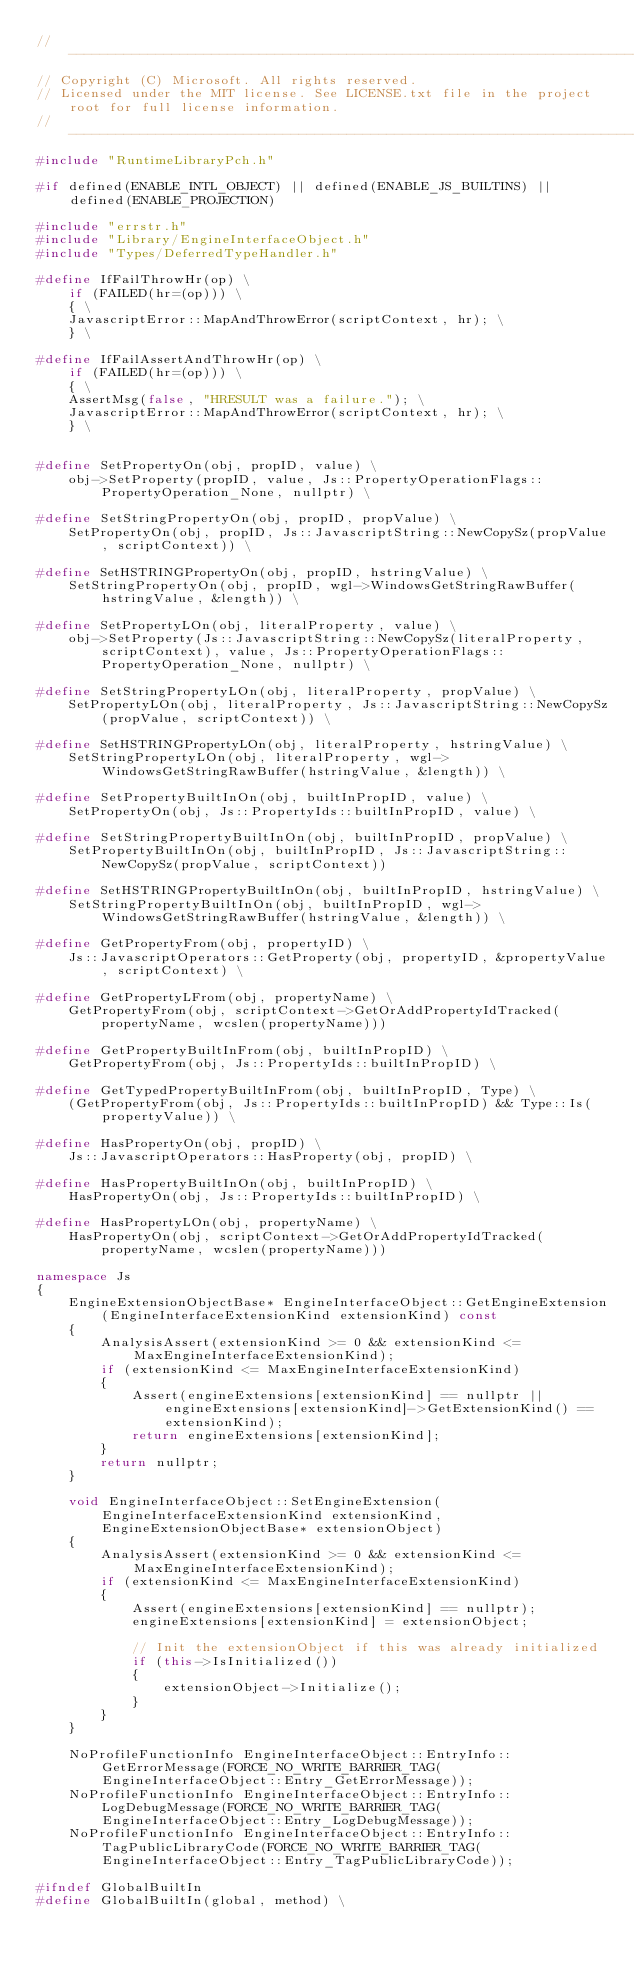<code> <loc_0><loc_0><loc_500><loc_500><_C++_>//-------------------------------------------------------------------------------------------------------
// Copyright (C) Microsoft. All rights reserved.
// Licensed under the MIT license. See LICENSE.txt file in the project root for full license information.
//-------------------------------------------------------------------------------------------------------
#include "RuntimeLibraryPch.h"

#if defined(ENABLE_INTL_OBJECT) || defined(ENABLE_JS_BUILTINS) || defined(ENABLE_PROJECTION)

#include "errstr.h"
#include "Library/EngineInterfaceObject.h"
#include "Types/DeferredTypeHandler.h"

#define IfFailThrowHr(op) \
    if (FAILED(hr=(op))) \
    { \
    JavascriptError::MapAndThrowError(scriptContext, hr); \
    } \

#define IfFailAssertAndThrowHr(op) \
    if (FAILED(hr=(op))) \
    { \
    AssertMsg(false, "HRESULT was a failure."); \
    JavascriptError::MapAndThrowError(scriptContext, hr); \
    } \


#define SetPropertyOn(obj, propID, value) \
    obj->SetProperty(propID, value, Js::PropertyOperationFlags::PropertyOperation_None, nullptr) \

#define SetStringPropertyOn(obj, propID, propValue) \
    SetPropertyOn(obj, propID, Js::JavascriptString::NewCopySz(propValue, scriptContext)) \

#define SetHSTRINGPropertyOn(obj, propID, hstringValue) \
    SetStringPropertyOn(obj, propID, wgl->WindowsGetStringRawBuffer(hstringValue, &length)) \

#define SetPropertyLOn(obj, literalProperty, value) \
    obj->SetProperty(Js::JavascriptString::NewCopySz(literalProperty, scriptContext), value, Js::PropertyOperationFlags::PropertyOperation_None, nullptr) \

#define SetStringPropertyLOn(obj, literalProperty, propValue) \
    SetPropertyLOn(obj, literalProperty, Js::JavascriptString::NewCopySz(propValue, scriptContext)) \

#define SetHSTRINGPropertyLOn(obj, literalProperty, hstringValue) \
    SetStringPropertyLOn(obj, literalProperty, wgl->WindowsGetStringRawBuffer(hstringValue, &length)) \

#define SetPropertyBuiltInOn(obj, builtInPropID, value) \
    SetPropertyOn(obj, Js::PropertyIds::builtInPropID, value) \

#define SetStringPropertyBuiltInOn(obj, builtInPropID, propValue) \
    SetPropertyBuiltInOn(obj, builtInPropID, Js::JavascriptString::NewCopySz(propValue, scriptContext))

#define SetHSTRINGPropertyBuiltInOn(obj, builtInPropID, hstringValue) \
    SetStringPropertyBuiltInOn(obj, builtInPropID, wgl->WindowsGetStringRawBuffer(hstringValue, &length)) \

#define GetPropertyFrom(obj, propertyID) \
    Js::JavascriptOperators::GetProperty(obj, propertyID, &propertyValue, scriptContext) \

#define GetPropertyLFrom(obj, propertyName) \
    GetPropertyFrom(obj, scriptContext->GetOrAddPropertyIdTracked(propertyName, wcslen(propertyName)))

#define GetPropertyBuiltInFrom(obj, builtInPropID) \
    GetPropertyFrom(obj, Js::PropertyIds::builtInPropID) \

#define GetTypedPropertyBuiltInFrom(obj, builtInPropID, Type) \
    (GetPropertyFrom(obj, Js::PropertyIds::builtInPropID) && Type::Is(propertyValue)) \

#define HasPropertyOn(obj, propID) \
    Js::JavascriptOperators::HasProperty(obj, propID) \

#define HasPropertyBuiltInOn(obj, builtInPropID) \
    HasPropertyOn(obj, Js::PropertyIds::builtInPropID) \

#define HasPropertyLOn(obj, propertyName) \
    HasPropertyOn(obj, scriptContext->GetOrAddPropertyIdTracked(propertyName, wcslen(propertyName)))

namespace Js
{
    EngineExtensionObjectBase* EngineInterfaceObject::GetEngineExtension(EngineInterfaceExtensionKind extensionKind) const
    {
        AnalysisAssert(extensionKind >= 0 && extensionKind <= MaxEngineInterfaceExtensionKind);
        if (extensionKind <= MaxEngineInterfaceExtensionKind)
        {
            Assert(engineExtensions[extensionKind] == nullptr || engineExtensions[extensionKind]->GetExtensionKind() == extensionKind);
            return engineExtensions[extensionKind];
        }
        return nullptr;
    }

    void EngineInterfaceObject::SetEngineExtension(EngineInterfaceExtensionKind extensionKind, EngineExtensionObjectBase* extensionObject)
    {
        AnalysisAssert(extensionKind >= 0 && extensionKind <= MaxEngineInterfaceExtensionKind);
        if (extensionKind <= MaxEngineInterfaceExtensionKind)
        {
            Assert(engineExtensions[extensionKind] == nullptr);
            engineExtensions[extensionKind] = extensionObject;

            // Init the extensionObject if this was already initialized
            if (this->IsInitialized())
            {
                extensionObject->Initialize();
            }
        }
    }

    NoProfileFunctionInfo EngineInterfaceObject::EntryInfo::GetErrorMessage(FORCE_NO_WRITE_BARRIER_TAG(EngineInterfaceObject::Entry_GetErrorMessage));
    NoProfileFunctionInfo EngineInterfaceObject::EntryInfo::LogDebugMessage(FORCE_NO_WRITE_BARRIER_TAG(EngineInterfaceObject::Entry_LogDebugMessage));
    NoProfileFunctionInfo EngineInterfaceObject::EntryInfo::TagPublicLibraryCode(FORCE_NO_WRITE_BARRIER_TAG(EngineInterfaceObject::Entry_TagPublicLibraryCode));

#ifndef GlobalBuiltIn
#define GlobalBuiltIn(global, method) \</code> 